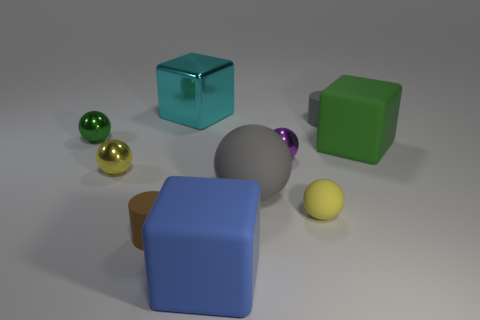There is a tiny cylinder that is behind the small purple object; is its color the same as the large rubber ball?
Your answer should be very brief. Yes. There is another sphere that is the same color as the tiny rubber sphere; what is it made of?
Provide a succinct answer. Metal. Are there fewer small yellow spheres in front of the gray ball than brown metallic things?
Give a very brief answer. No. Is the number of small gray matte cylinders on the left side of the cyan thing less than the number of large matte blocks that are behind the purple object?
Give a very brief answer. Yes. What number of balls are large blue matte objects or big metallic objects?
Your answer should be very brief. 0. Do the large cube in front of the small yellow metallic sphere and the yellow ball that is to the right of the small purple shiny ball have the same material?
Ensure brevity in your answer.  Yes. What shape is the gray thing that is the same size as the green rubber thing?
Offer a terse response. Sphere. How many other objects are the same color as the shiny cube?
Provide a short and direct response. 0. What number of blue things are either large matte blocks or shiny objects?
Your answer should be very brief. 1. Does the small yellow object that is on the right side of the blue thing have the same shape as the small yellow thing to the left of the cyan metallic block?
Give a very brief answer. Yes. 